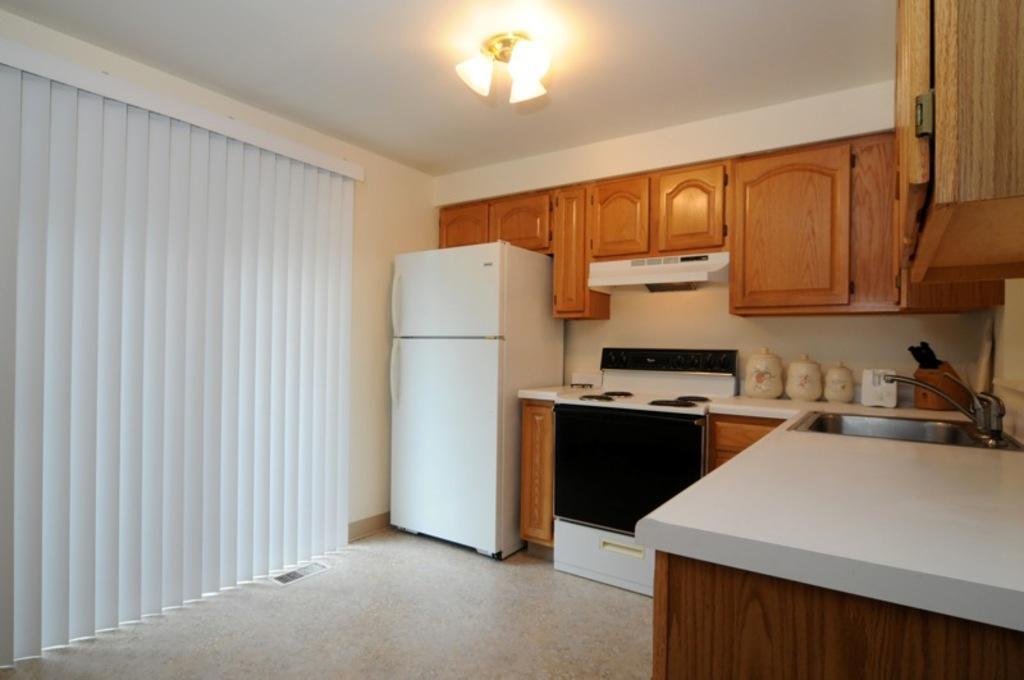Could you give a brief overview of what you see in this image? In this picture I can observe a kitchen. On the right side there is a white color desk. I can observe a refrigerator in the middle of the picture. There are some cupboards which are in brown color. On the right side I can observe a sink and a tap. On the left side I can observe white color curtain. 